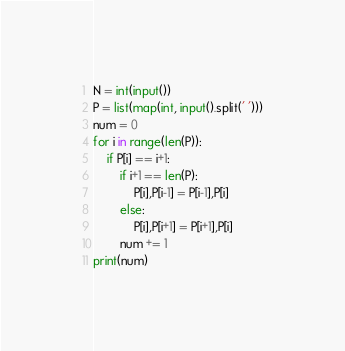Convert code to text. <code><loc_0><loc_0><loc_500><loc_500><_Python_>N = int(input())
P = list(map(int, input().split(' ')))
num = 0
for i in range(len(P)):
    if P[i] == i+1:
        if i+1 == len(P):
            P[i],P[i-1] = P[i-1],P[i]
        else:
            P[i],P[i+1] = P[i+1],P[i]
        num += 1
print(num)
</code> 